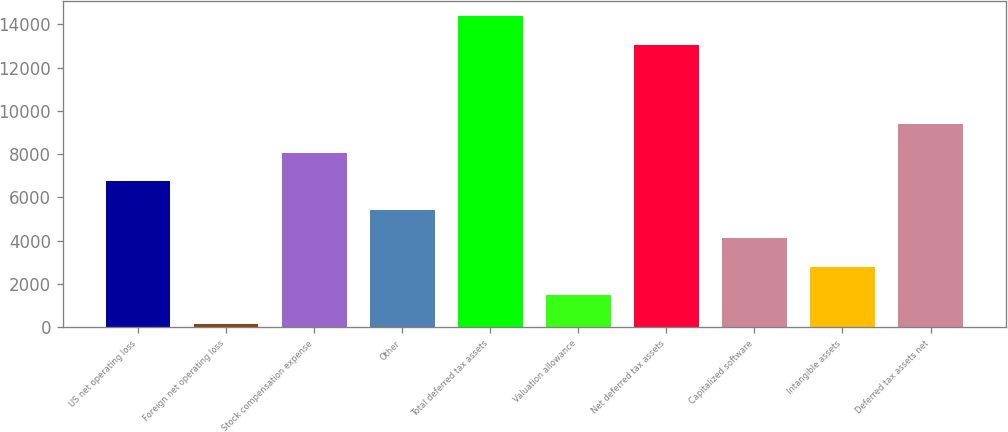Convert chart to OTSL. <chart><loc_0><loc_0><loc_500><loc_500><bar_chart><fcel>US net operating loss<fcel>Foreign net operating loss<fcel>Stock compensation expense<fcel>Other<fcel>Total deferred tax assets<fcel>Valuation allowance<fcel>Net deferred tax assets<fcel>Capitalized software<fcel>Intangible assets<fcel>Deferred tax assets net<nl><fcel>6755.5<fcel>165<fcel>8073.6<fcel>5437.4<fcel>14377.1<fcel>1483.1<fcel>13059<fcel>4119.3<fcel>2801.2<fcel>9391.7<nl></chart> 